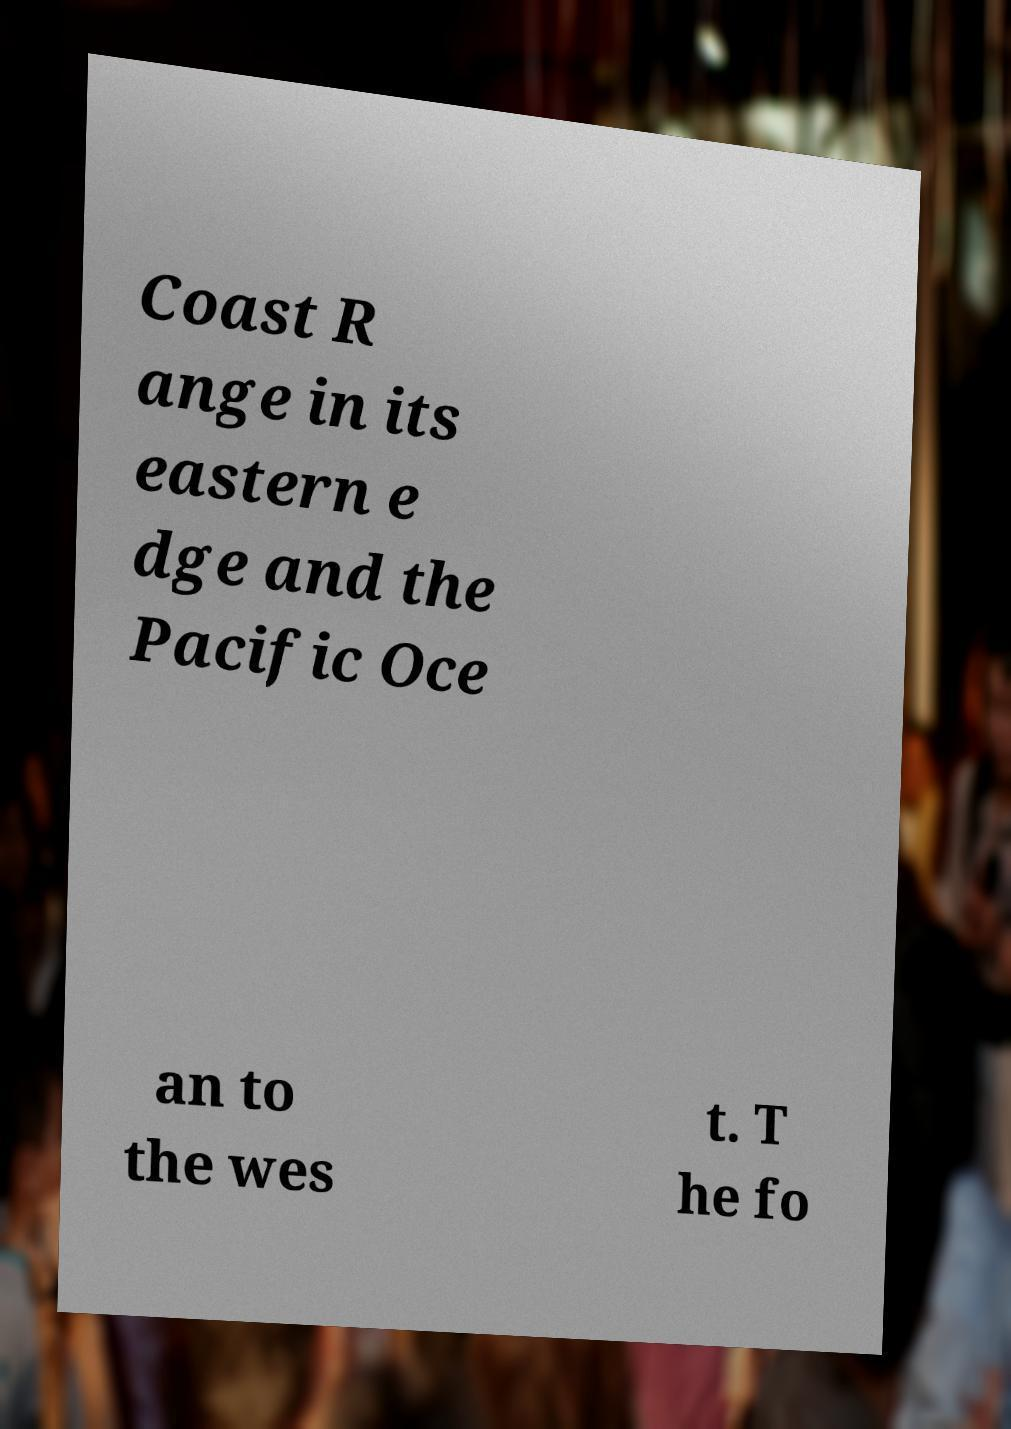Could you assist in decoding the text presented in this image and type it out clearly? Coast R ange in its eastern e dge and the Pacific Oce an to the wes t. T he fo 